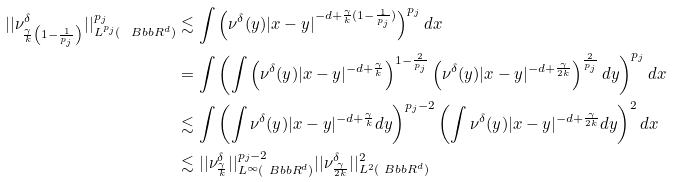<formula> <loc_0><loc_0><loc_500><loc_500>| | \nu _ { \frac { \gamma } { k } \left ( 1 - \frac { 1 } { p _ { j } } \right ) } ^ { \delta } | | _ { L ^ { p _ { j } } ( { \ B b b R } ^ { d } ) } ^ { p _ { j } } & \lesssim \int \left ( \nu ^ { \delta } ( y ) | x - y | ^ { - d + \frac { \gamma } { k } ( 1 - \frac { 1 } { p _ { j } } ) } \right ) ^ { p _ { j } } d x \\ & = \int \left ( \int \left ( \nu ^ { \delta } ( y ) | x - y | ^ { - d + \frac { \gamma } { k } } \right ) ^ { 1 - \frac { 2 } { p _ { j } } } \left ( \nu ^ { \delta } ( y ) | x - y | ^ { - d + \frac { \gamma } { 2 k } } \right ) ^ { \frac { 2 } { p _ { j } } } d y \right ) ^ { p _ { j } } d x \\ & \lesssim \int \left ( \int \nu ^ { \delta } ( y ) | x - y | ^ { - d + \frac { \gamma } { k } } d y \right ) ^ { p _ { j } - 2 } \left ( \int \nu ^ { \delta } ( y ) | x - y | ^ { - d + \frac { \gamma } { 2 k } } d y \right ) ^ { 2 } d x \\ & \lesssim | | \nu _ { \frac { \gamma } { k } } ^ { \delta } | | _ { L ^ { \infty } ( { \ B b b R } ^ { d } ) } ^ { p _ { j } - 2 } | | \nu _ { \frac { \gamma } { 2 k } } ^ { \delta } | | _ { L ^ { 2 } ( { \ B b b R } ^ { d } ) } ^ { 2 }</formula> 